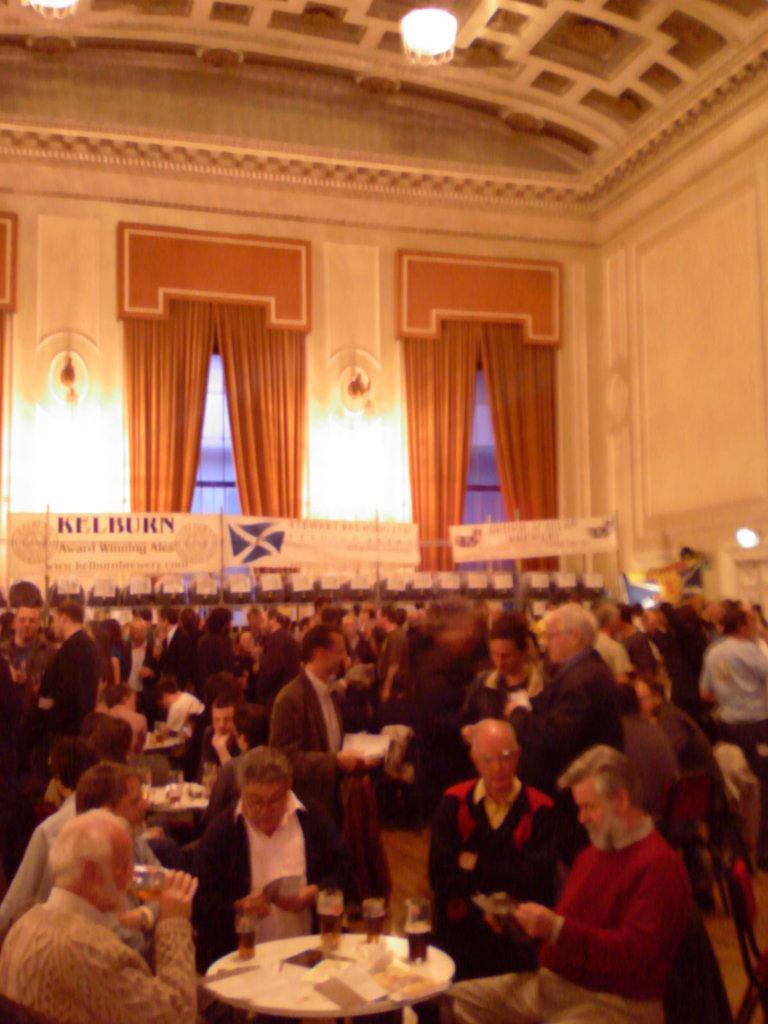What type of structure is visible in the image? There is a building in the image. How many windows can be seen on the building? The building has two windows. What is covering the windows? There are curtains associated with the windows. What are the people near the table doing? People are sitting on chairs near a table. What is on the table? There is a glass and papers on the table. What else can be seen in the image? There are posters in the image. What type of fang can be seen in the image? There is no fang present in the image. How many chairs are visible in the image? The image shows people sitting on chairs, but it does not specify the exact number of chairs. 